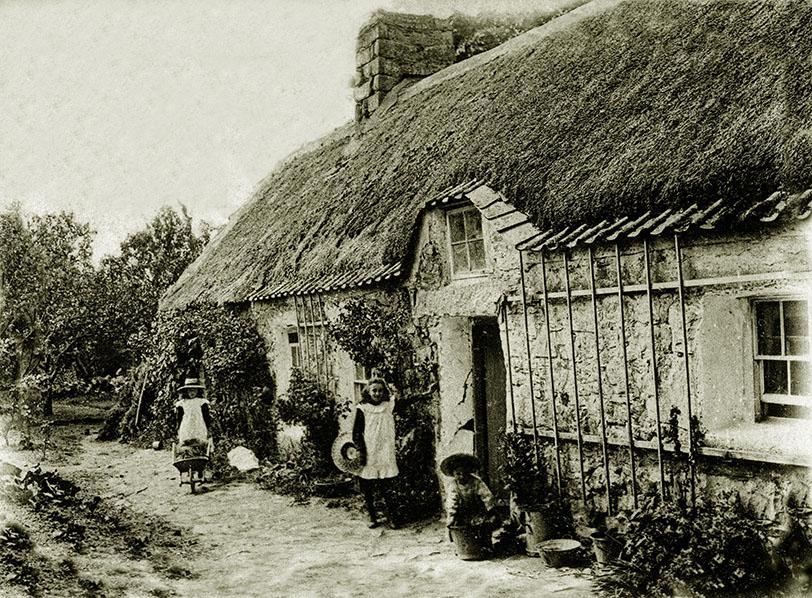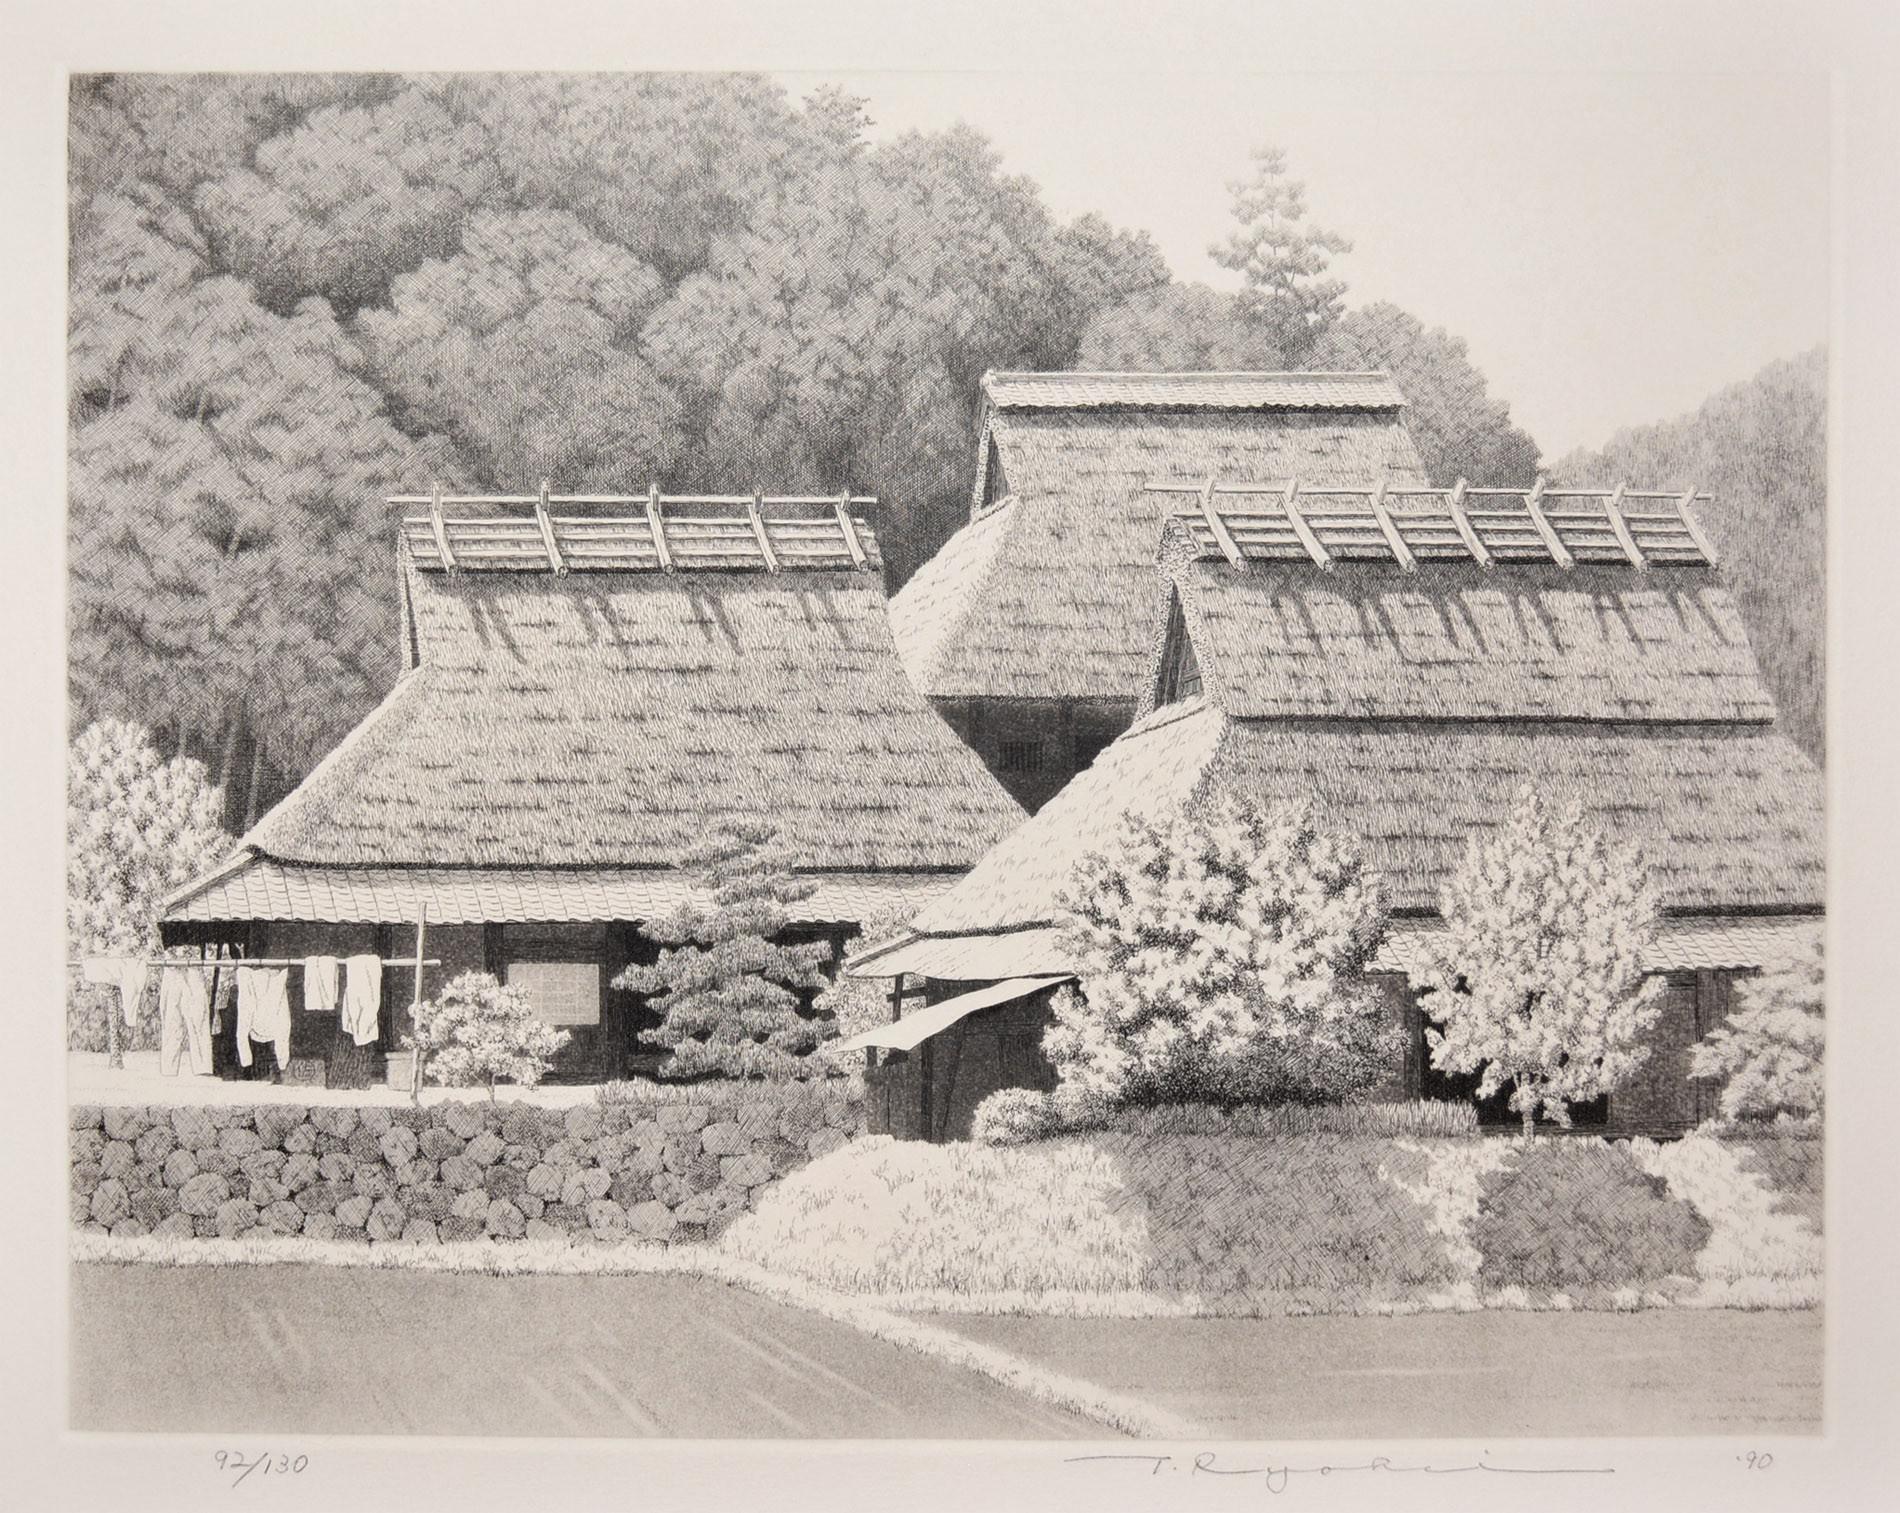The first image is the image on the left, the second image is the image on the right. Considering the images on both sides, is "There are people in front of a building." valid? Answer yes or no. Yes. 